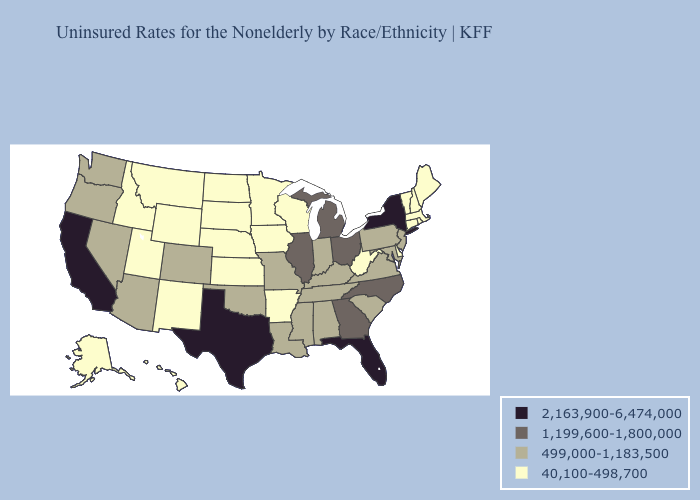What is the highest value in states that border Montana?
Short answer required. 40,100-498,700. What is the value of Montana?
Give a very brief answer. 40,100-498,700. Name the states that have a value in the range 1,199,600-1,800,000?
Write a very short answer. Georgia, Illinois, Michigan, North Carolina, Ohio. What is the highest value in states that border New York?
Be succinct. 499,000-1,183,500. What is the highest value in states that border Mississippi?
Be succinct. 499,000-1,183,500. What is the highest value in states that border Utah?
Write a very short answer. 499,000-1,183,500. Name the states that have a value in the range 2,163,900-6,474,000?
Concise answer only. California, Florida, New York, Texas. What is the highest value in the Northeast ?
Answer briefly. 2,163,900-6,474,000. Name the states that have a value in the range 499,000-1,183,500?
Concise answer only. Alabama, Arizona, Colorado, Indiana, Kentucky, Louisiana, Maryland, Mississippi, Missouri, Nevada, New Jersey, Oklahoma, Oregon, Pennsylvania, South Carolina, Tennessee, Virginia, Washington. What is the value of New Jersey?
Be succinct. 499,000-1,183,500. Does the first symbol in the legend represent the smallest category?
Write a very short answer. No. Name the states that have a value in the range 1,199,600-1,800,000?
Quick response, please. Georgia, Illinois, Michigan, North Carolina, Ohio. Which states have the lowest value in the USA?
Keep it brief. Alaska, Arkansas, Connecticut, Delaware, Hawaii, Idaho, Iowa, Kansas, Maine, Massachusetts, Minnesota, Montana, Nebraska, New Hampshire, New Mexico, North Dakota, Rhode Island, South Dakota, Utah, Vermont, West Virginia, Wisconsin, Wyoming. Among the states that border Virginia , does West Virginia have the lowest value?
Answer briefly. Yes. Does North Dakota have a higher value than Pennsylvania?
Give a very brief answer. No. 